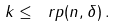<formula> <loc_0><loc_0><loc_500><loc_500>k \leq \ r p ( n , \delta ) \, .</formula> 